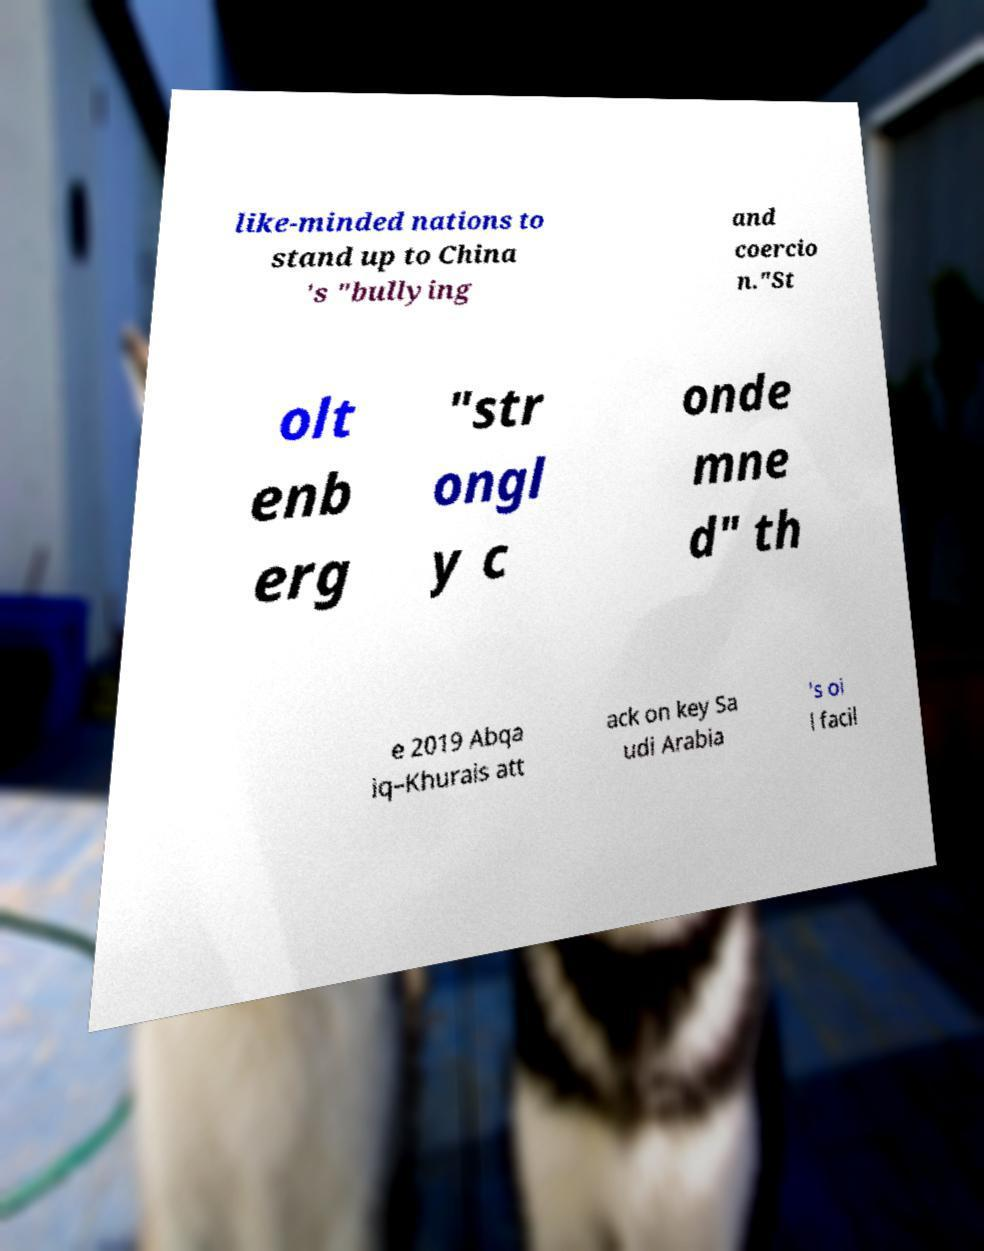Can you read and provide the text displayed in the image?This photo seems to have some interesting text. Can you extract and type it out for me? like-minded nations to stand up to China 's "bullying and coercio n."St olt enb erg "str ongl y c onde mne d" th e 2019 Abqa iq–Khurais att ack on key Sa udi Arabia 's oi l facil 